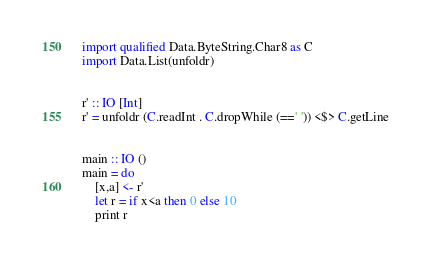Convert code to text. <code><loc_0><loc_0><loc_500><loc_500><_Haskell_>
import qualified Data.ByteString.Char8 as C
import Data.List(unfoldr)


r' :: IO [Int]
r' = unfoldr (C.readInt . C.dropWhile (==' ')) <$> C.getLine


main :: IO ()
main = do
    [x,a] <- r'
    let r = if x<a then 0 else 10
    print r
</code> 